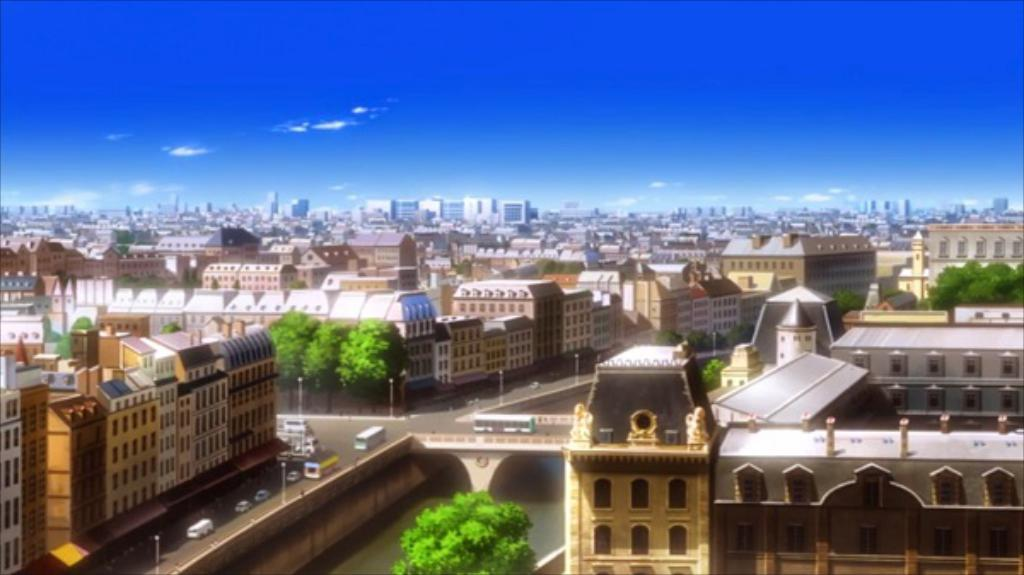What is the main subject in the center of the image? There is water in the center of the image. What can be seen on top of the water? There are vehicles on a bridge in the image. What type of natural elements are visible in the background of the image? There are trees and the sky visible in the background of the image. What type of man-made structures can be seen in the background of the image? There are buildings and street lights visible in the background of the image. How many oranges are hanging from the trees in the image? There are no oranges visible in the image; only trees are present in the background. What phase is the moon in during the image? There is no moon visible in the image; only the sky is visible in the background. 